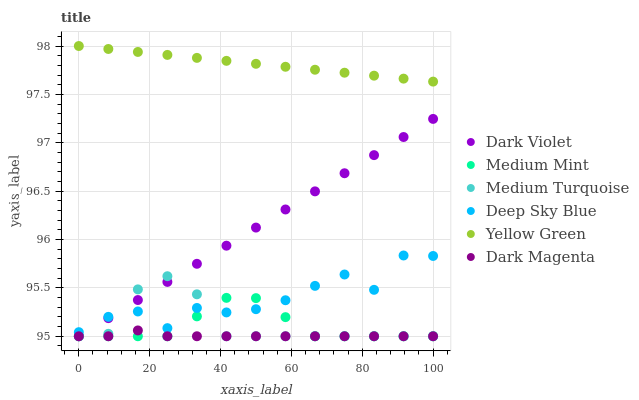Does Dark Magenta have the minimum area under the curve?
Answer yes or no. Yes. Does Yellow Green have the maximum area under the curve?
Answer yes or no. Yes. Does Medium Turquoise have the minimum area under the curve?
Answer yes or no. No. Does Medium Turquoise have the maximum area under the curve?
Answer yes or no. No. Is Yellow Green the smoothest?
Answer yes or no. Yes. Is Deep Sky Blue the roughest?
Answer yes or no. Yes. Is Medium Turquoise the smoothest?
Answer yes or no. No. Is Medium Turquoise the roughest?
Answer yes or no. No. Does Medium Mint have the lowest value?
Answer yes or no. Yes. Does Deep Sky Blue have the lowest value?
Answer yes or no. No. Does Yellow Green have the highest value?
Answer yes or no. Yes. Does Medium Turquoise have the highest value?
Answer yes or no. No. Is Dark Magenta less than Yellow Green?
Answer yes or no. Yes. Is Yellow Green greater than Dark Violet?
Answer yes or no. Yes. Does Medium Turquoise intersect Dark Violet?
Answer yes or no. Yes. Is Medium Turquoise less than Dark Violet?
Answer yes or no. No. Is Medium Turquoise greater than Dark Violet?
Answer yes or no. No. Does Dark Magenta intersect Yellow Green?
Answer yes or no. No. 